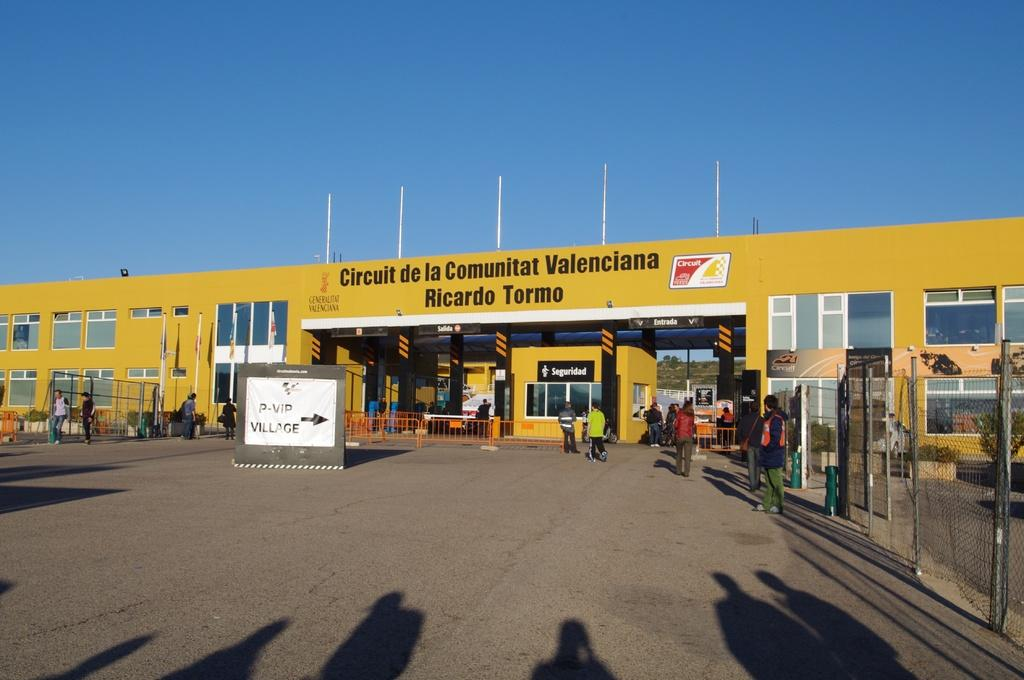<image>
Render a clear and concise summary of the photo. A large yellow building has the words Circuit de la Comunitat Valenciana on the top. 